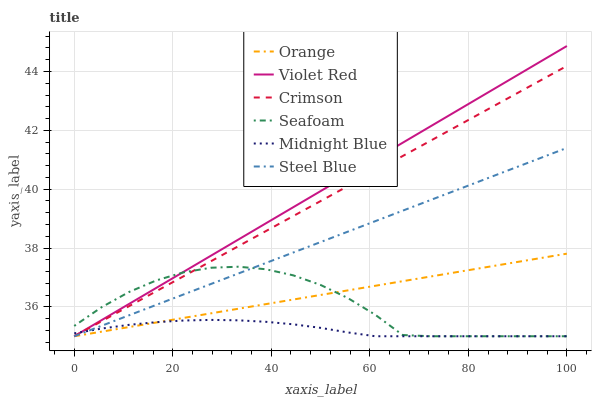Does Midnight Blue have the minimum area under the curve?
Answer yes or no. Yes. Does Violet Red have the maximum area under the curve?
Answer yes or no. Yes. Does Seafoam have the minimum area under the curve?
Answer yes or no. No. Does Seafoam have the maximum area under the curve?
Answer yes or no. No. Is Orange the smoothest?
Answer yes or no. Yes. Is Seafoam the roughest?
Answer yes or no. Yes. Is Midnight Blue the smoothest?
Answer yes or no. No. Is Midnight Blue the roughest?
Answer yes or no. No. Does Violet Red have the lowest value?
Answer yes or no. Yes. Does Violet Red have the highest value?
Answer yes or no. Yes. Does Seafoam have the highest value?
Answer yes or no. No. Does Orange intersect Violet Red?
Answer yes or no. Yes. Is Orange less than Violet Red?
Answer yes or no. No. Is Orange greater than Violet Red?
Answer yes or no. No. 